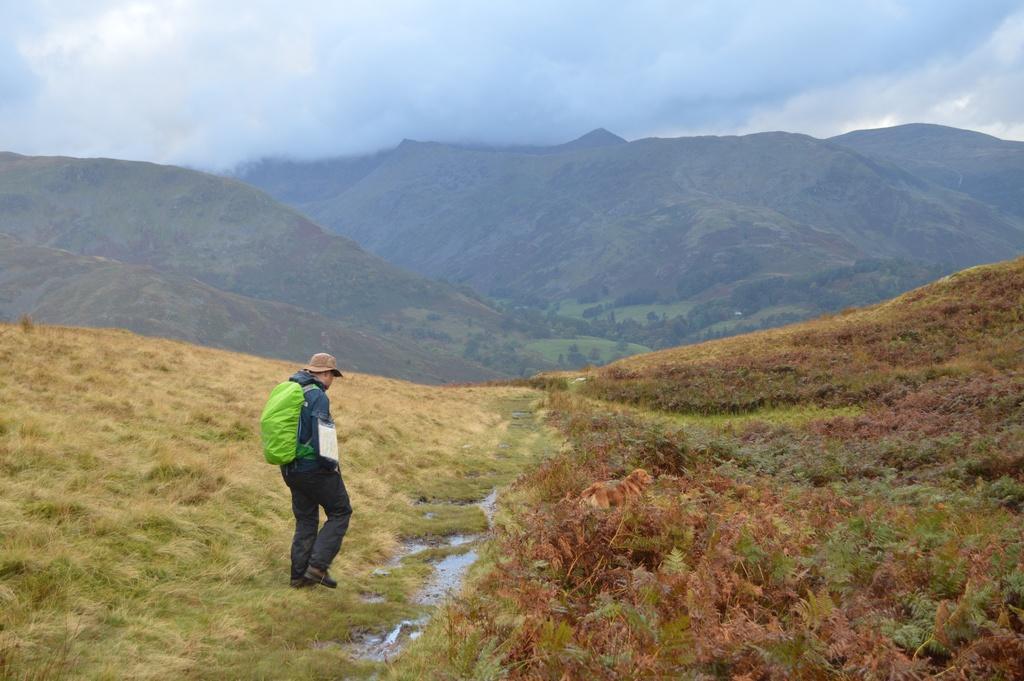Could you give a brief overview of what you see in this image? This image is taken outdoors. At the top of the image there is a sky with clouds. At the bottom of the image there is a ground with grass and plants on it. In the middle of the image a man is walking on the ground. In the background there are a few hills and there are many trees and plants. 